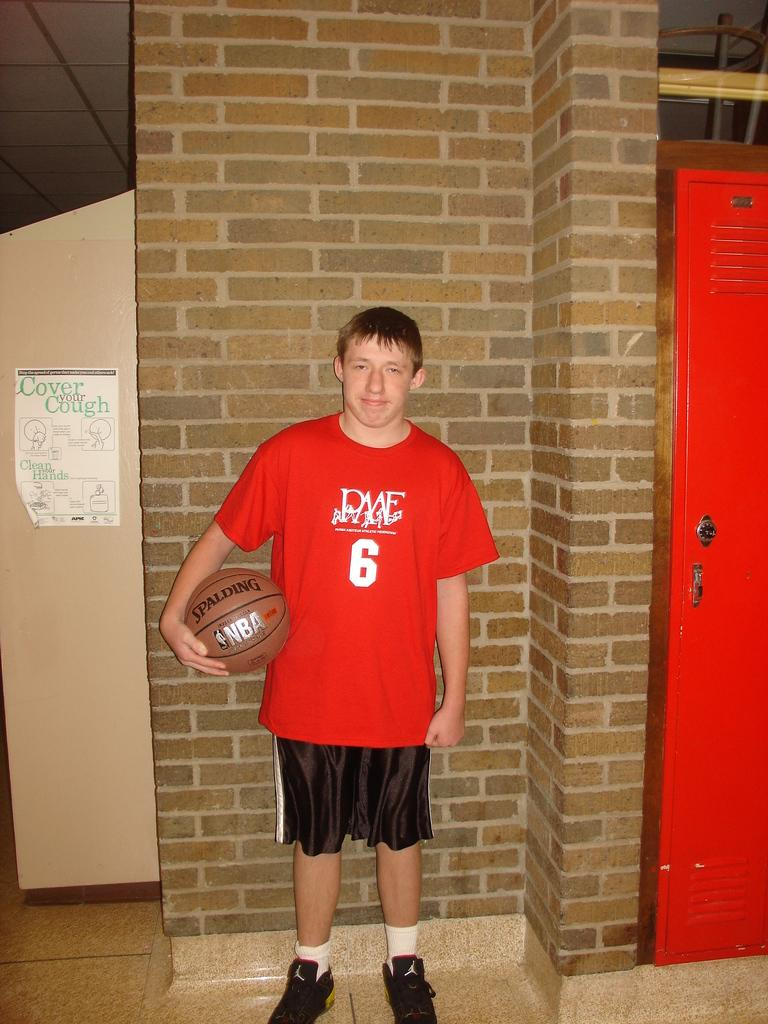<image>
Describe the image concisely. A boy wears a red shirt with the number 6, while a paper advises you to Cover your Cough. 